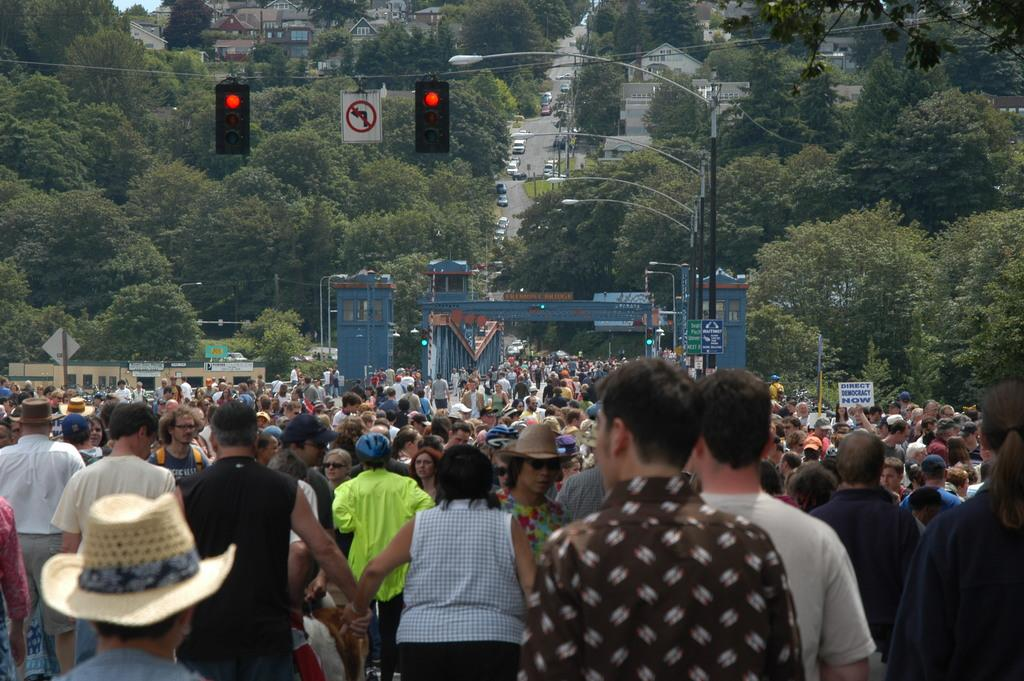How many people are present in the image? There are many people in the image. What can be seen controlling the flow of traffic in the image? There are traffic signals in the image. What type of information might be conveyed by the sign boards in the image? The sign boards in the image might convey information about directions, warnings, or advertisements. What type of vegetation is visible in the image? There are trees in the image. What type of transportation is visible on the road in the image? There are vehicles on the road in the image. What type of structures can be seen in the background of the image? There are buildings at the back of the image. Where is the key located in the image? There is no key present in the image. What type of furniture is the drawer attached to in the image? There is no drawer present in the image. What is the stick used for in the image? There is no stick present in the image. 